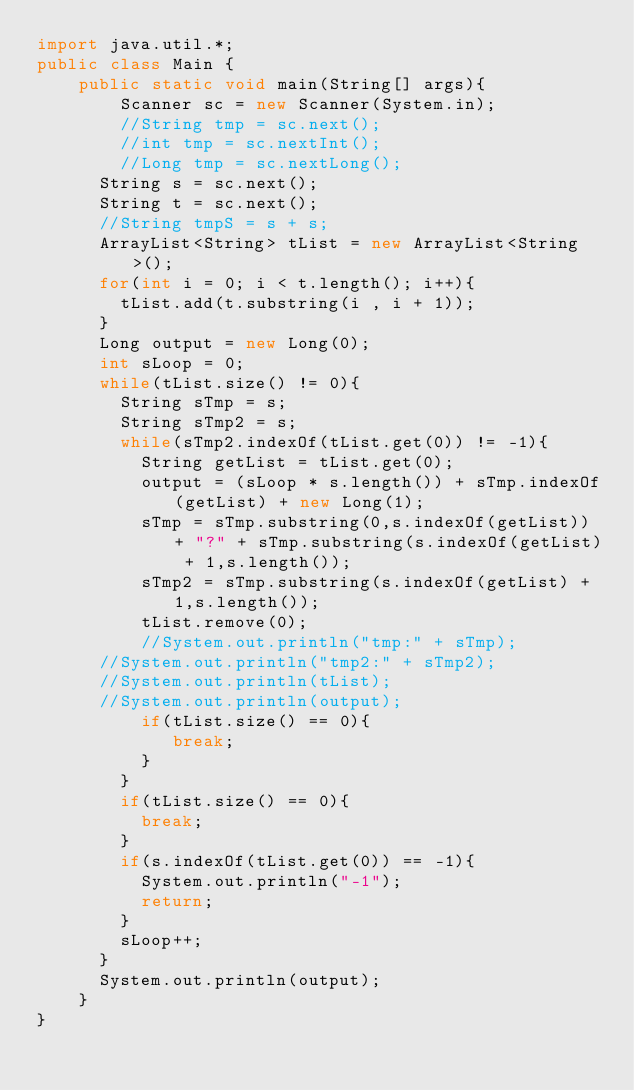Convert code to text. <code><loc_0><loc_0><loc_500><loc_500><_Java_>import java.util.*;
public class Main {
	public static void main(String[] args){
		Scanner sc = new Scanner(System.in);
		//String tmp = sc.next();
		//int tmp = sc.nextInt();
		//Long tmp = sc.nextLong();
      String s = sc.next();
      String t = sc.next();
      //String tmpS = s + s;
      ArrayList<String> tList = new ArrayList<String>();
      for(int i = 0; i < t.length(); i++){
        tList.add(t.substring(i , i + 1));
      }
      Long output = new Long(0);
      int sLoop = 0;
      while(tList.size() != 0){
        String sTmp = s;
        String sTmp2 = s;
        while(sTmp2.indexOf(tList.get(0)) != -1){
          String getList = tList.get(0);
          output = (sLoop * s.length()) + sTmp.indexOf(getList) + new Long(1);
          sTmp = sTmp.substring(0,s.indexOf(getList)) + "?" + sTmp.substring(s.indexOf(getList) + 1,s.length());
          sTmp2 = sTmp.substring(s.indexOf(getList) + 1,s.length());
          tList.remove(0);
          //System.out.println("tmp:" + sTmp);
      //System.out.println("tmp2:" + sTmp2);
      //System.out.println(tList);
      //System.out.println(output);
          if(tList.size() == 0){
       		 break;
      	  }
        }
        if(tList.size() == 0){
          break;
        }
        if(s.indexOf(tList.get(0)) == -1){
          System.out.println("-1");
          return;
        }
        sLoop++;
      }
      System.out.println(output);
	}
}
</code> 